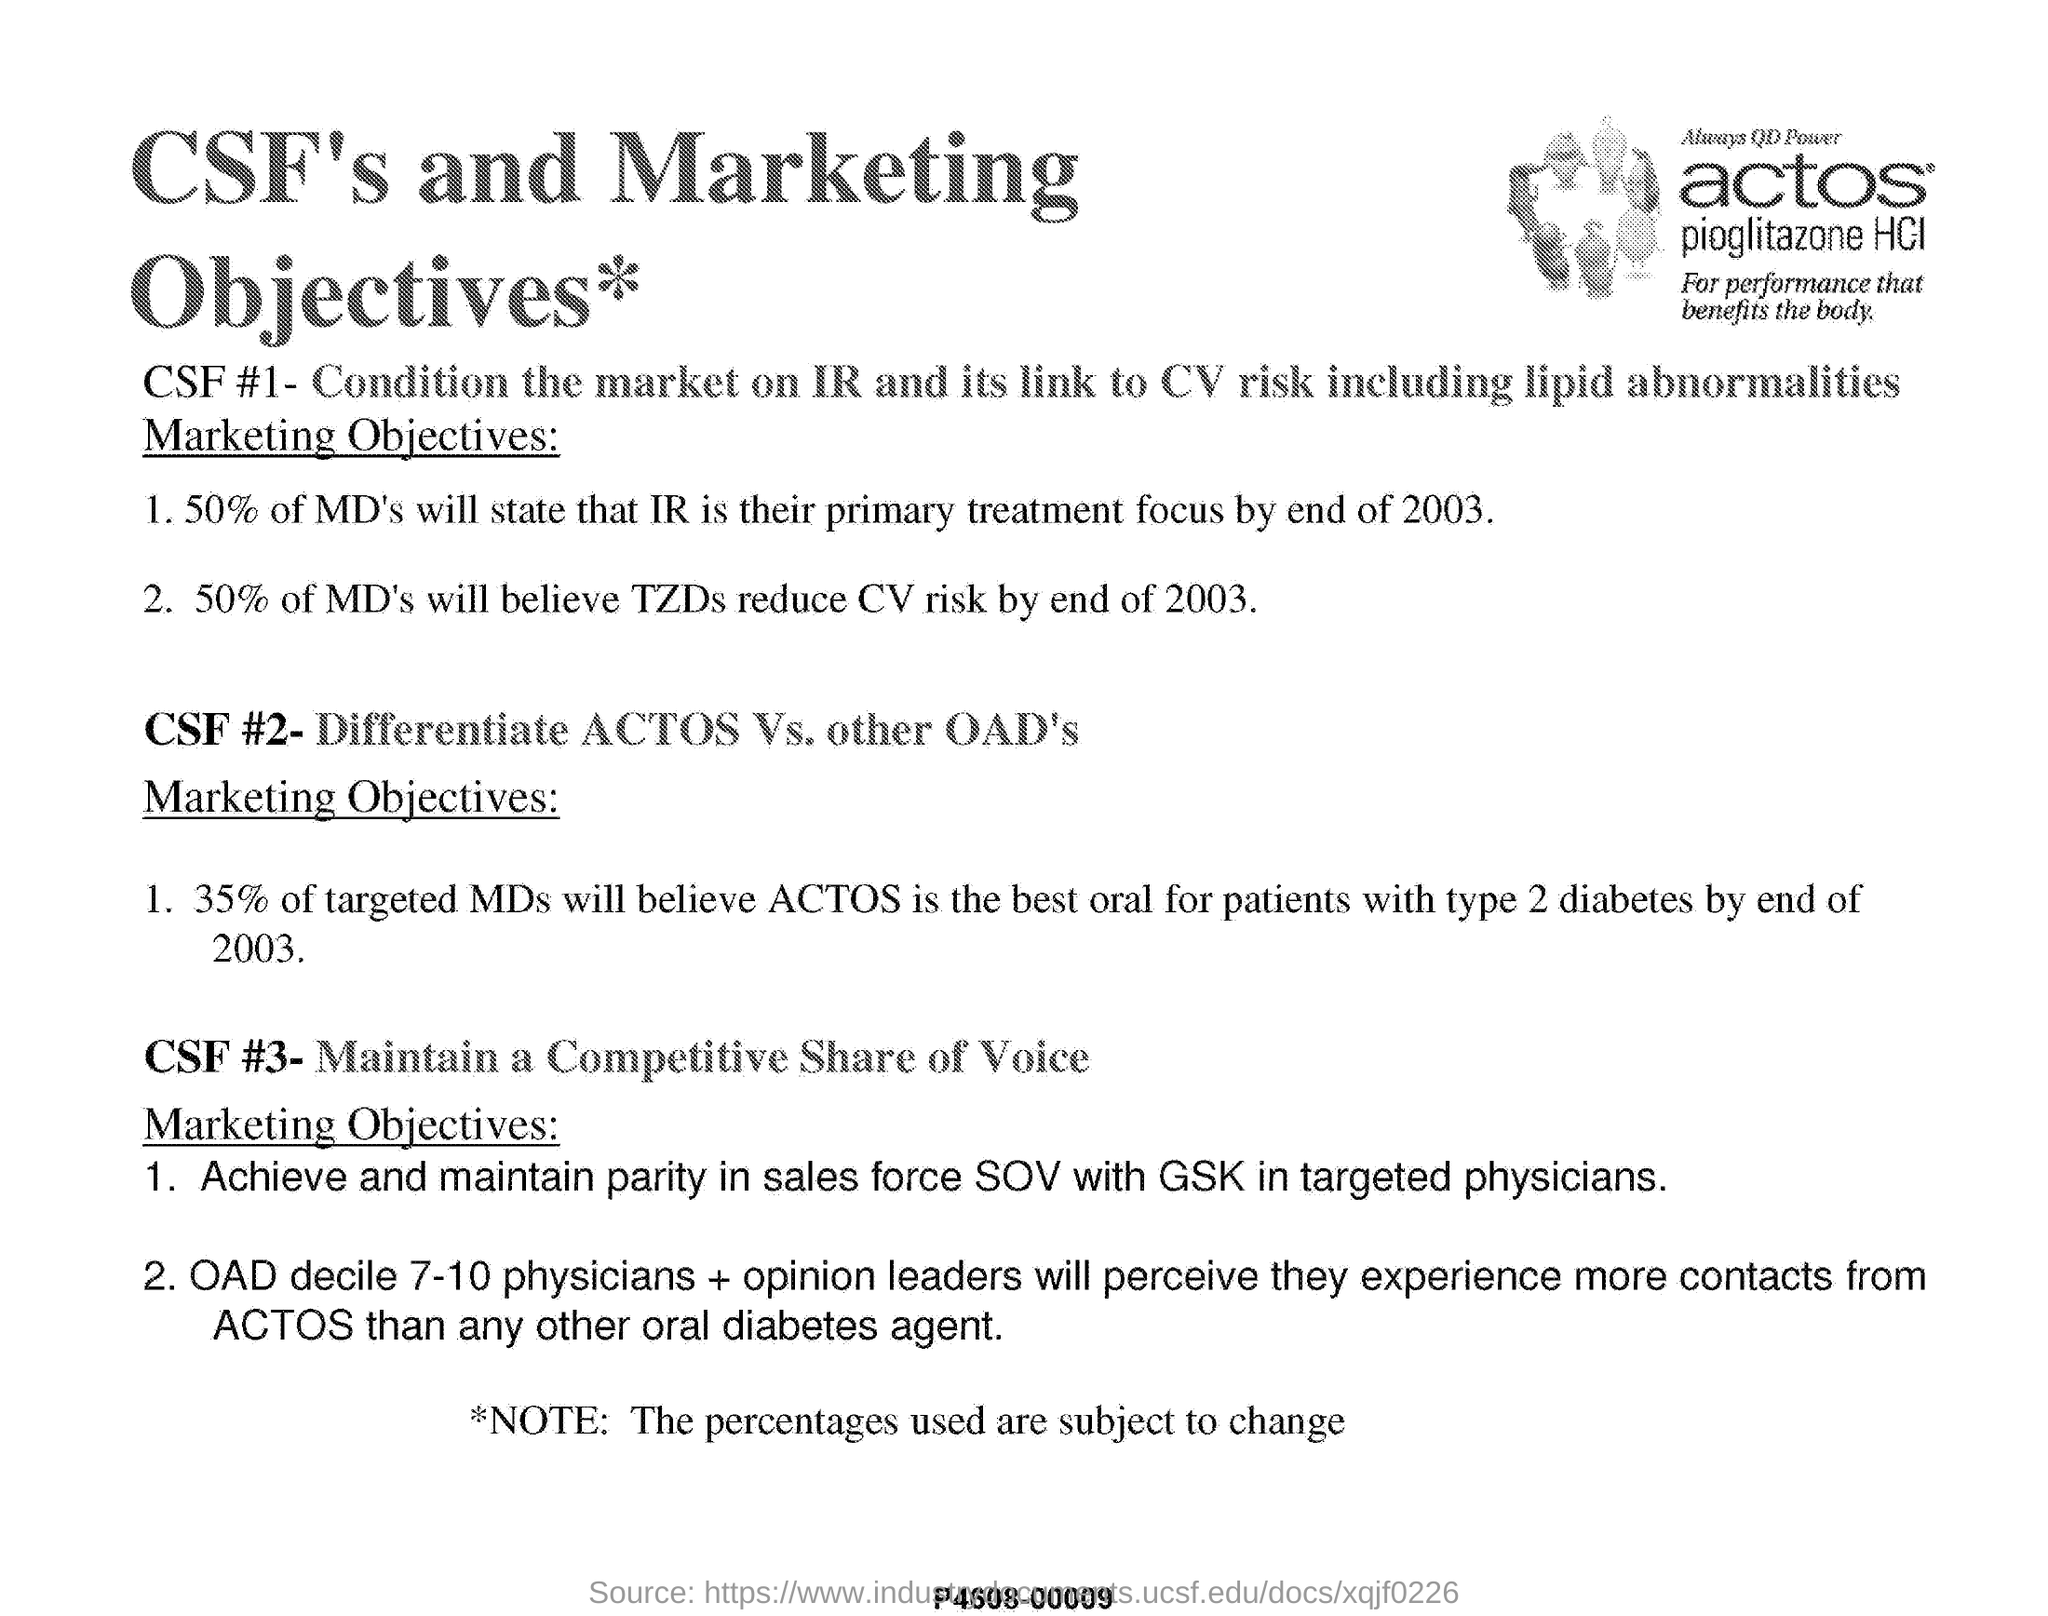Specify some key components in this picture. The title of this document is 'CSF'S AND MARKETING OBJECTIVES.' 